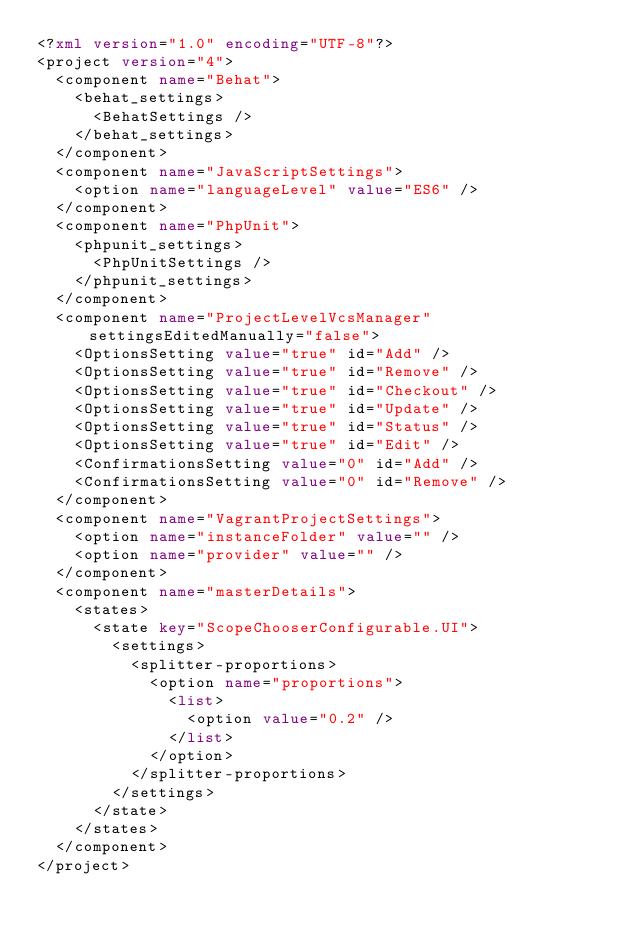Convert code to text. <code><loc_0><loc_0><loc_500><loc_500><_XML_><?xml version="1.0" encoding="UTF-8"?>
<project version="4">
  <component name="Behat">
    <behat_settings>
      <BehatSettings />
    </behat_settings>
  </component>
  <component name="JavaScriptSettings">
    <option name="languageLevel" value="ES6" />
  </component>
  <component name="PhpUnit">
    <phpunit_settings>
      <PhpUnitSettings />
    </phpunit_settings>
  </component>
  <component name="ProjectLevelVcsManager" settingsEditedManually="false">
    <OptionsSetting value="true" id="Add" />
    <OptionsSetting value="true" id="Remove" />
    <OptionsSetting value="true" id="Checkout" />
    <OptionsSetting value="true" id="Update" />
    <OptionsSetting value="true" id="Status" />
    <OptionsSetting value="true" id="Edit" />
    <ConfirmationsSetting value="0" id="Add" />
    <ConfirmationsSetting value="0" id="Remove" />
  </component>
  <component name="VagrantProjectSettings">
    <option name="instanceFolder" value="" />
    <option name="provider" value="" />
  </component>
  <component name="masterDetails">
    <states>
      <state key="ScopeChooserConfigurable.UI">
        <settings>
          <splitter-proportions>
            <option name="proportions">
              <list>
                <option value="0.2" />
              </list>
            </option>
          </splitter-proportions>
        </settings>
      </state>
    </states>
  </component>
</project></code> 